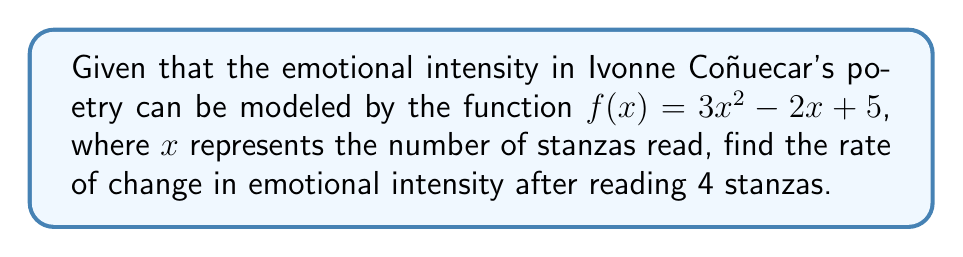Could you help me with this problem? To find the rate of change in emotional intensity, we need to calculate the derivative of the given function and evaluate it at $x = 4$.

Step 1: Find the derivative of $f(x)$.
$$f(x) = 3x^2 - 2x + 5$$
$$f'(x) = 6x - 2$$

Step 2: Evaluate the derivative at $x = 4$.
$$f'(4) = 6(4) - 2$$
$$f'(4) = 24 - 2$$
$$f'(4) = 22$$

The rate of change in emotional intensity after reading 4 stanzas is 22 units per stanza.
Answer: 22 units per stanza 